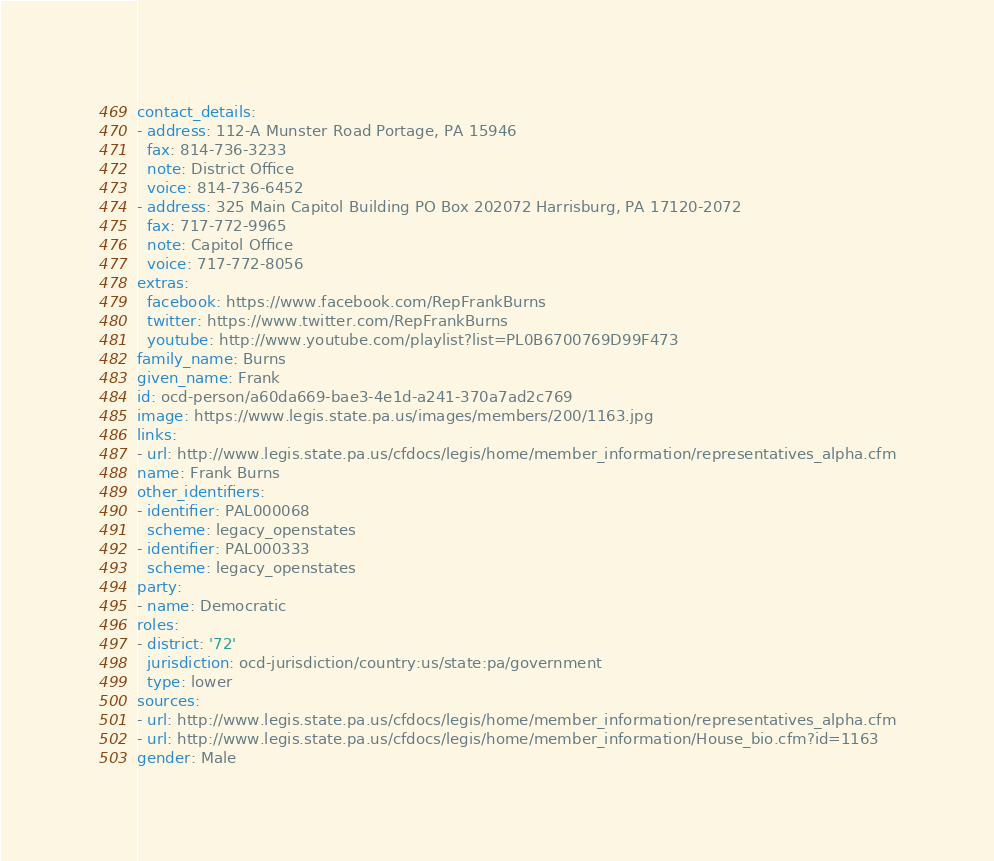<code> <loc_0><loc_0><loc_500><loc_500><_YAML_>contact_details:
- address: 112-A Munster Road Portage, PA 15946
  fax: 814-736-3233
  note: District Office
  voice: 814-736-6452
- address: 325 Main Capitol Building PO Box 202072 Harrisburg, PA 17120-2072
  fax: 717-772-9965
  note: Capitol Office
  voice: 717-772-8056
extras:
  facebook: https://www.facebook.com/RepFrankBurns
  twitter: https://www.twitter.com/RepFrankBurns
  youtube: http://www.youtube.com/playlist?list=PL0B6700769D99F473
family_name: Burns
given_name: Frank
id: ocd-person/a60da669-bae3-4e1d-a241-370a7ad2c769
image: https://www.legis.state.pa.us/images/members/200/1163.jpg
links:
- url: http://www.legis.state.pa.us/cfdocs/legis/home/member_information/representatives_alpha.cfm
name: Frank Burns
other_identifiers:
- identifier: PAL000068
  scheme: legacy_openstates
- identifier: PAL000333
  scheme: legacy_openstates
party:
- name: Democratic
roles:
- district: '72'
  jurisdiction: ocd-jurisdiction/country:us/state:pa/government
  type: lower
sources:
- url: http://www.legis.state.pa.us/cfdocs/legis/home/member_information/representatives_alpha.cfm
- url: http://www.legis.state.pa.us/cfdocs/legis/home/member_information/House_bio.cfm?id=1163
gender: Male
</code> 